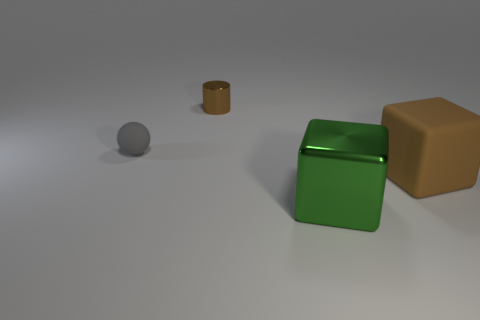Add 1 small brown cylinders. How many objects exist? 5 Subtract all cylinders. How many objects are left? 3 Add 4 tiny yellow rubber cylinders. How many tiny yellow rubber cylinders exist? 4 Subtract 0 gray cubes. How many objects are left? 4 Subtract all small yellow cylinders. Subtract all cylinders. How many objects are left? 3 Add 4 tiny gray spheres. How many tiny gray spheres are left? 5 